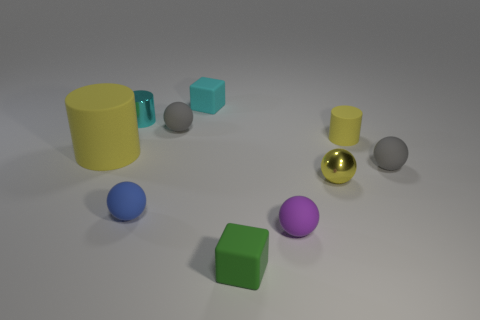Subtract all tiny blue spheres. How many spheres are left? 4 Subtract all yellow spheres. How many spheres are left? 4 Subtract 2 spheres. How many spheres are left? 3 Subtract all tiny yellow spheres. Subtract all tiny cyan cylinders. How many objects are left? 8 Add 4 blue matte things. How many blue matte things are left? 5 Add 3 blue balls. How many blue balls exist? 4 Subtract 0 brown spheres. How many objects are left? 10 Subtract all cylinders. How many objects are left? 7 Subtract all green cylinders. Subtract all yellow balls. How many cylinders are left? 3 Subtract all brown spheres. How many blue cylinders are left? 0 